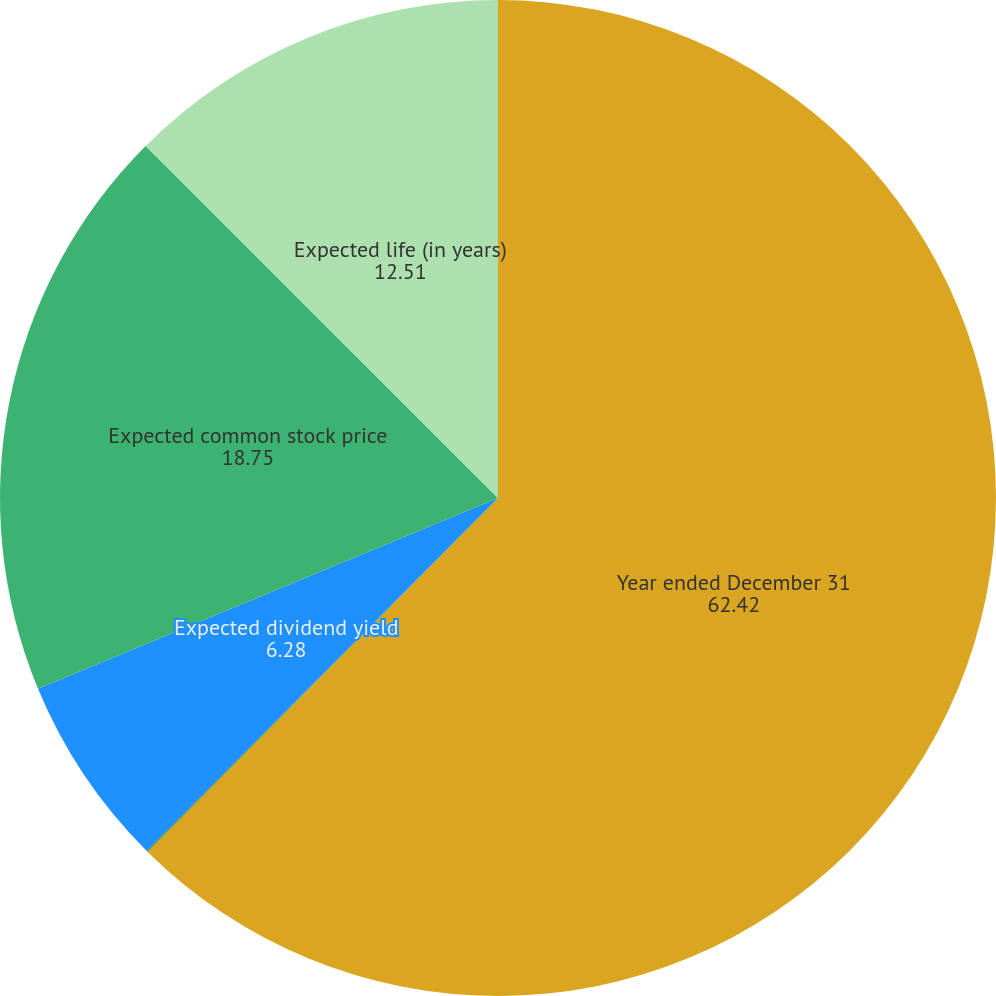<chart> <loc_0><loc_0><loc_500><loc_500><pie_chart><fcel>Year ended December 31<fcel>Risk-free interest rate<fcel>Expected dividend yield<fcel>Expected common stock price<fcel>Expected life (in years)<nl><fcel>62.42%<fcel>0.04%<fcel>6.28%<fcel>18.75%<fcel>12.51%<nl></chart> 